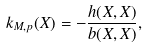<formula> <loc_0><loc_0><loc_500><loc_500>k _ { M , p } ( X ) = - \frac { h ( X , X ) } { b ( X , X ) } ,</formula> 